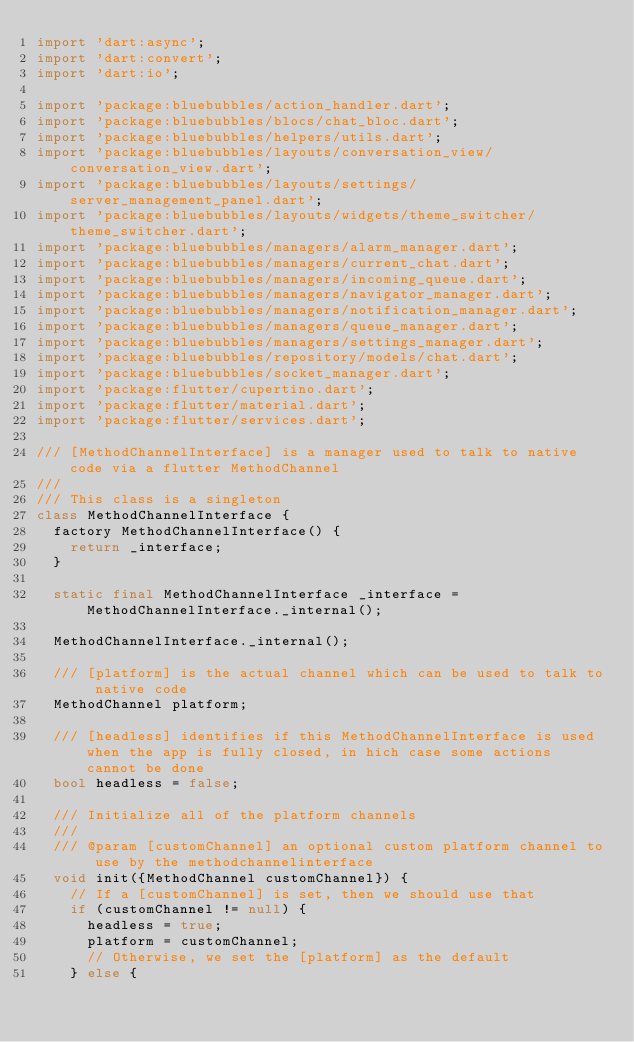Convert code to text. <code><loc_0><loc_0><loc_500><loc_500><_Dart_>import 'dart:async';
import 'dart:convert';
import 'dart:io';

import 'package:bluebubbles/action_handler.dart';
import 'package:bluebubbles/blocs/chat_bloc.dart';
import 'package:bluebubbles/helpers/utils.dart';
import 'package:bluebubbles/layouts/conversation_view/conversation_view.dart';
import 'package:bluebubbles/layouts/settings/server_management_panel.dart';
import 'package:bluebubbles/layouts/widgets/theme_switcher/theme_switcher.dart';
import 'package:bluebubbles/managers/alarm_manager.dart';
import 'package:bluebubbles/managers/current_chat.dart';
import 'package:bluebubbles/managers/incoming_queue.dart';
import 'package:bluebubbles/managers/navigator_manager.dart';
import 'package:bluebubbles/managers/notification_manager.dart';
import 'package:bluebubbles/managers/queue_manager.dart';
import 'package:bluebubbles/managers/settings_manager.dart';
import 'package:bluebubbles/repository/models/chat.dart';
import 'package:bluebubbles/socket_manager.dart';
import 'package:flutter/cupertino.dart';
import 'package:flutter/material.dart';
import 'package:flutter/services.dart';

/// [MethodChannelInterface] is a manager used to talk to native code via a flutter MethodChannel
///
/// This class is a singleton
class MethodChannelInterface {
  factory MethodChannelInterface() {
    return _interface;
  }

  static final MethodChannelInterface _interface = MethodChannelInterface._internal();

  MethodChannelInterface._internal();

  /// [platform] is the actual channel which can be used to talk to native code
  MethodChannel platform;

  /// [headless] identifies if this MethodChannelInterface is used when the app is fully closed, in hich case some actions cannot be done
  bool headless = false;

  /// Initialize all of the platform channels
  ///
  /// @param [customChannel] an optional custom platform channel to use by the methodchannelinterface
  void init({MethodChannel customChannel}) {
    // If a [customChannel] is set, then we should use that
    if (customChannel != null) {
      headless = true;
      platform = customChannel;
      // Otherwise, we set the [platform] as the default
    } else {</code> 